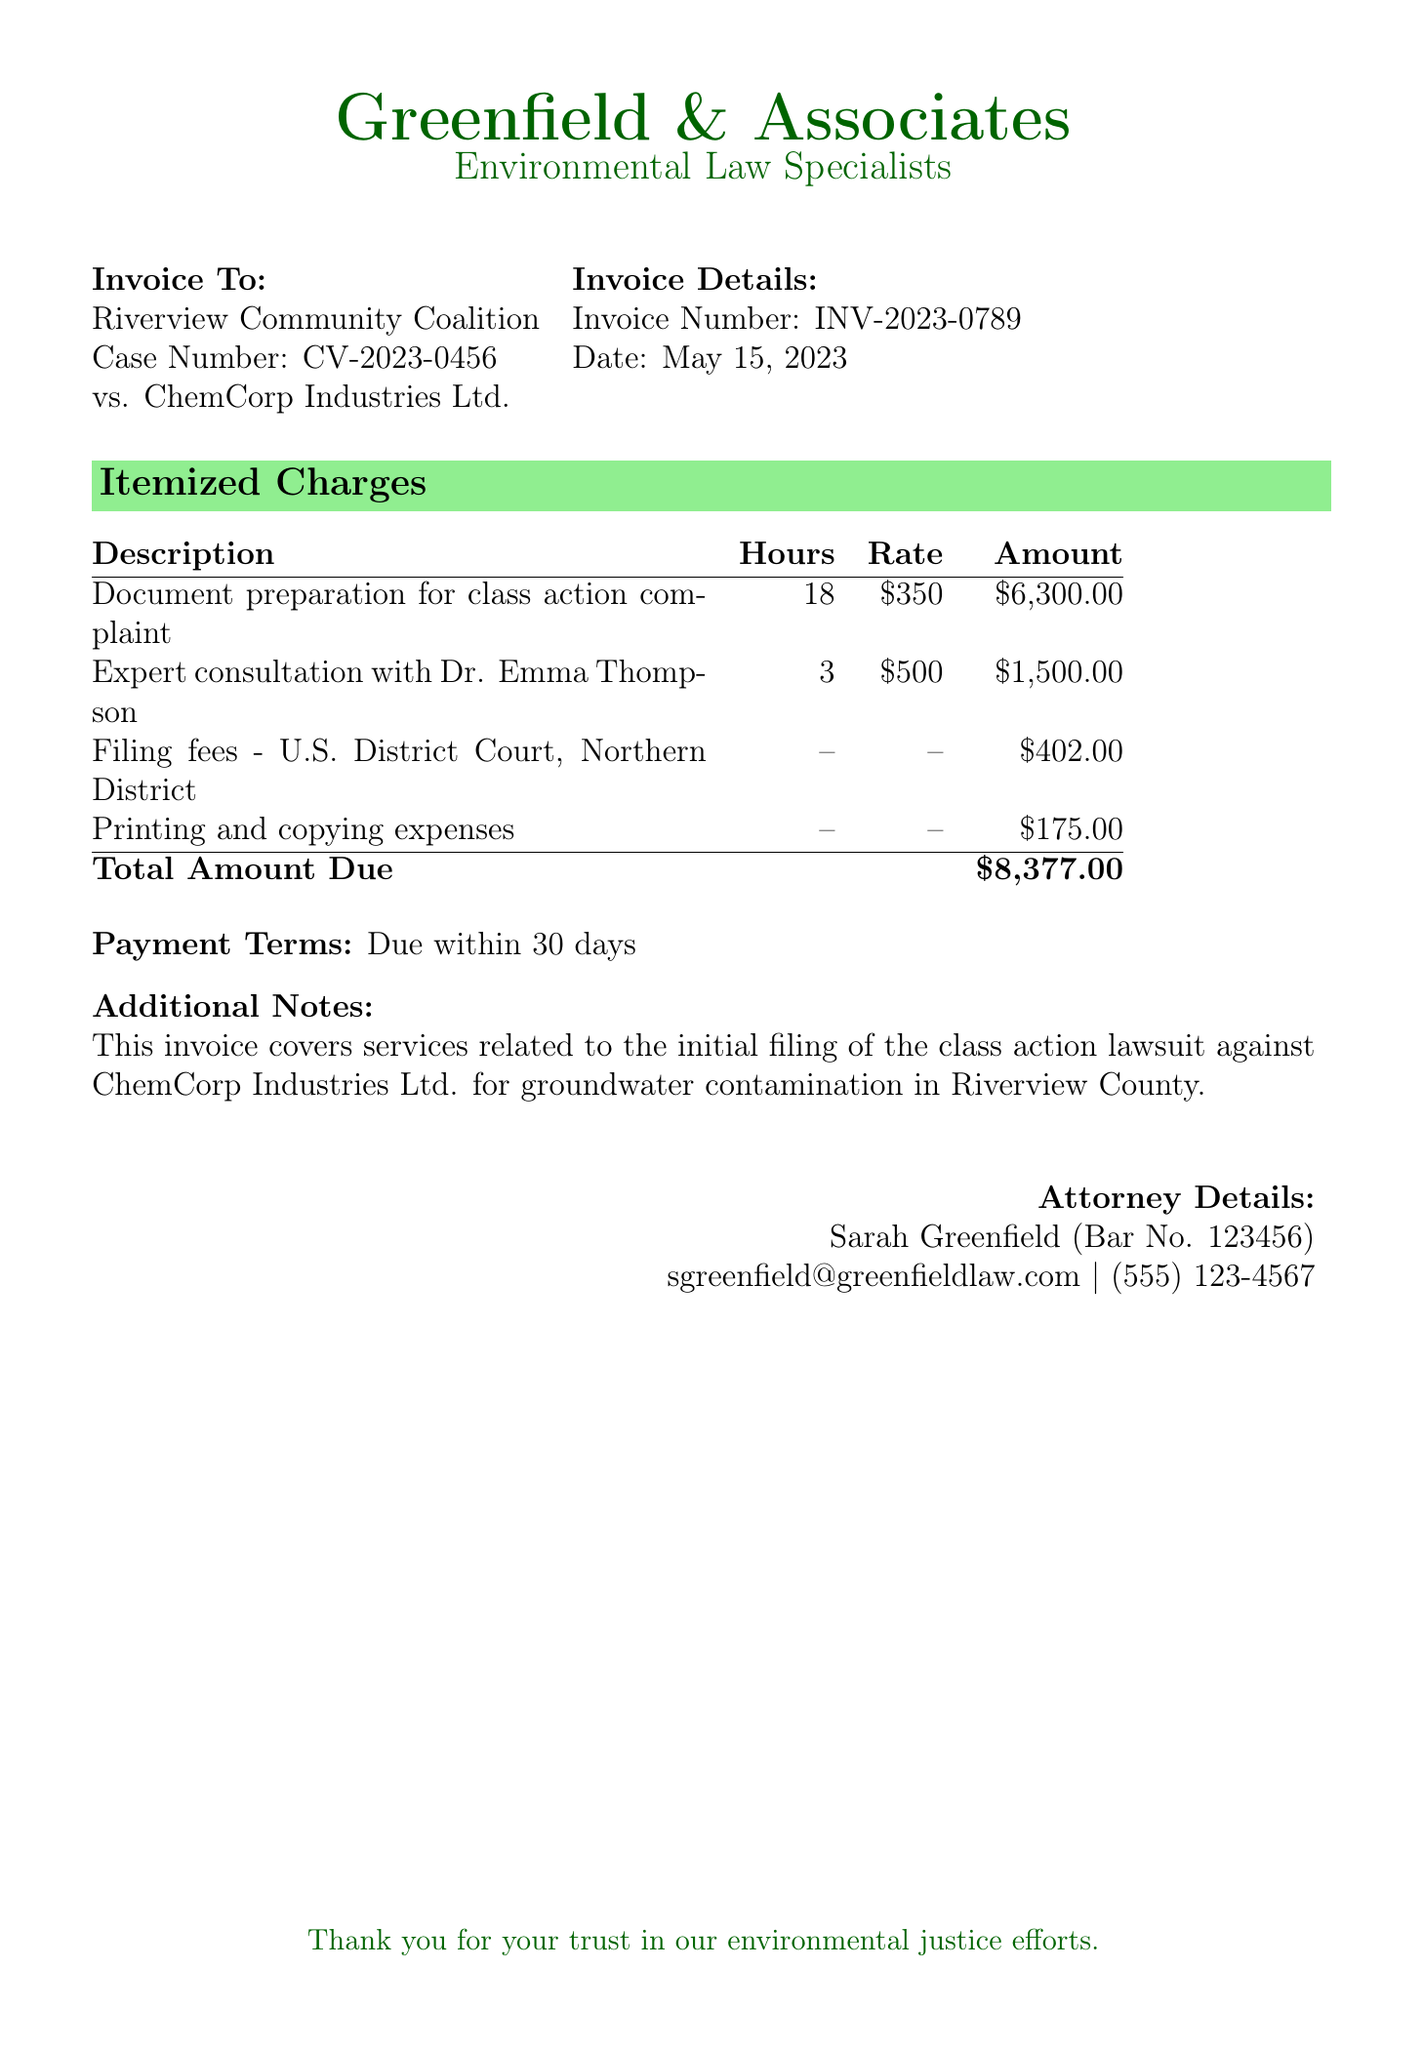what is the invoice number? The invoice number is provided in the invoice details section of the document.
Answer: INV-2023-0789 what is the total amount due? The total amount is calculated based on the itemized charges listed in the document.
Answer: $8,377.00 who is the attorney handling this case? The name of the attorney is located at the bottom of the document under "Attorney Details."
Answer: Sarah Greenfield when is the payment due? The payment terms specify a timeframe for payment listed in the document.
Answer: 30 days how many hours were spent on document preparation for the class action complaint? The hours for document preparation are indicated in the itemized charges section.
Answer: 18 what is the filing fee for the U.S. District Court? The filing fee is mentioned in the itemized charges under "Filing fees."
Answer: $402.00 who is the expert consultant mentioned in the invoice? The expert consultant's name is listed in the itemized charges for expert consultation.
Answer: Dr. Emma Thompson what is the date of the invoice? The date is given in the invoice details section of the document.
Answer: May 15, 2023 what type of lawsuit is being filed? The type of lawsuit is specified in the additional notes section of the document.
Answer: class action lawsuit 